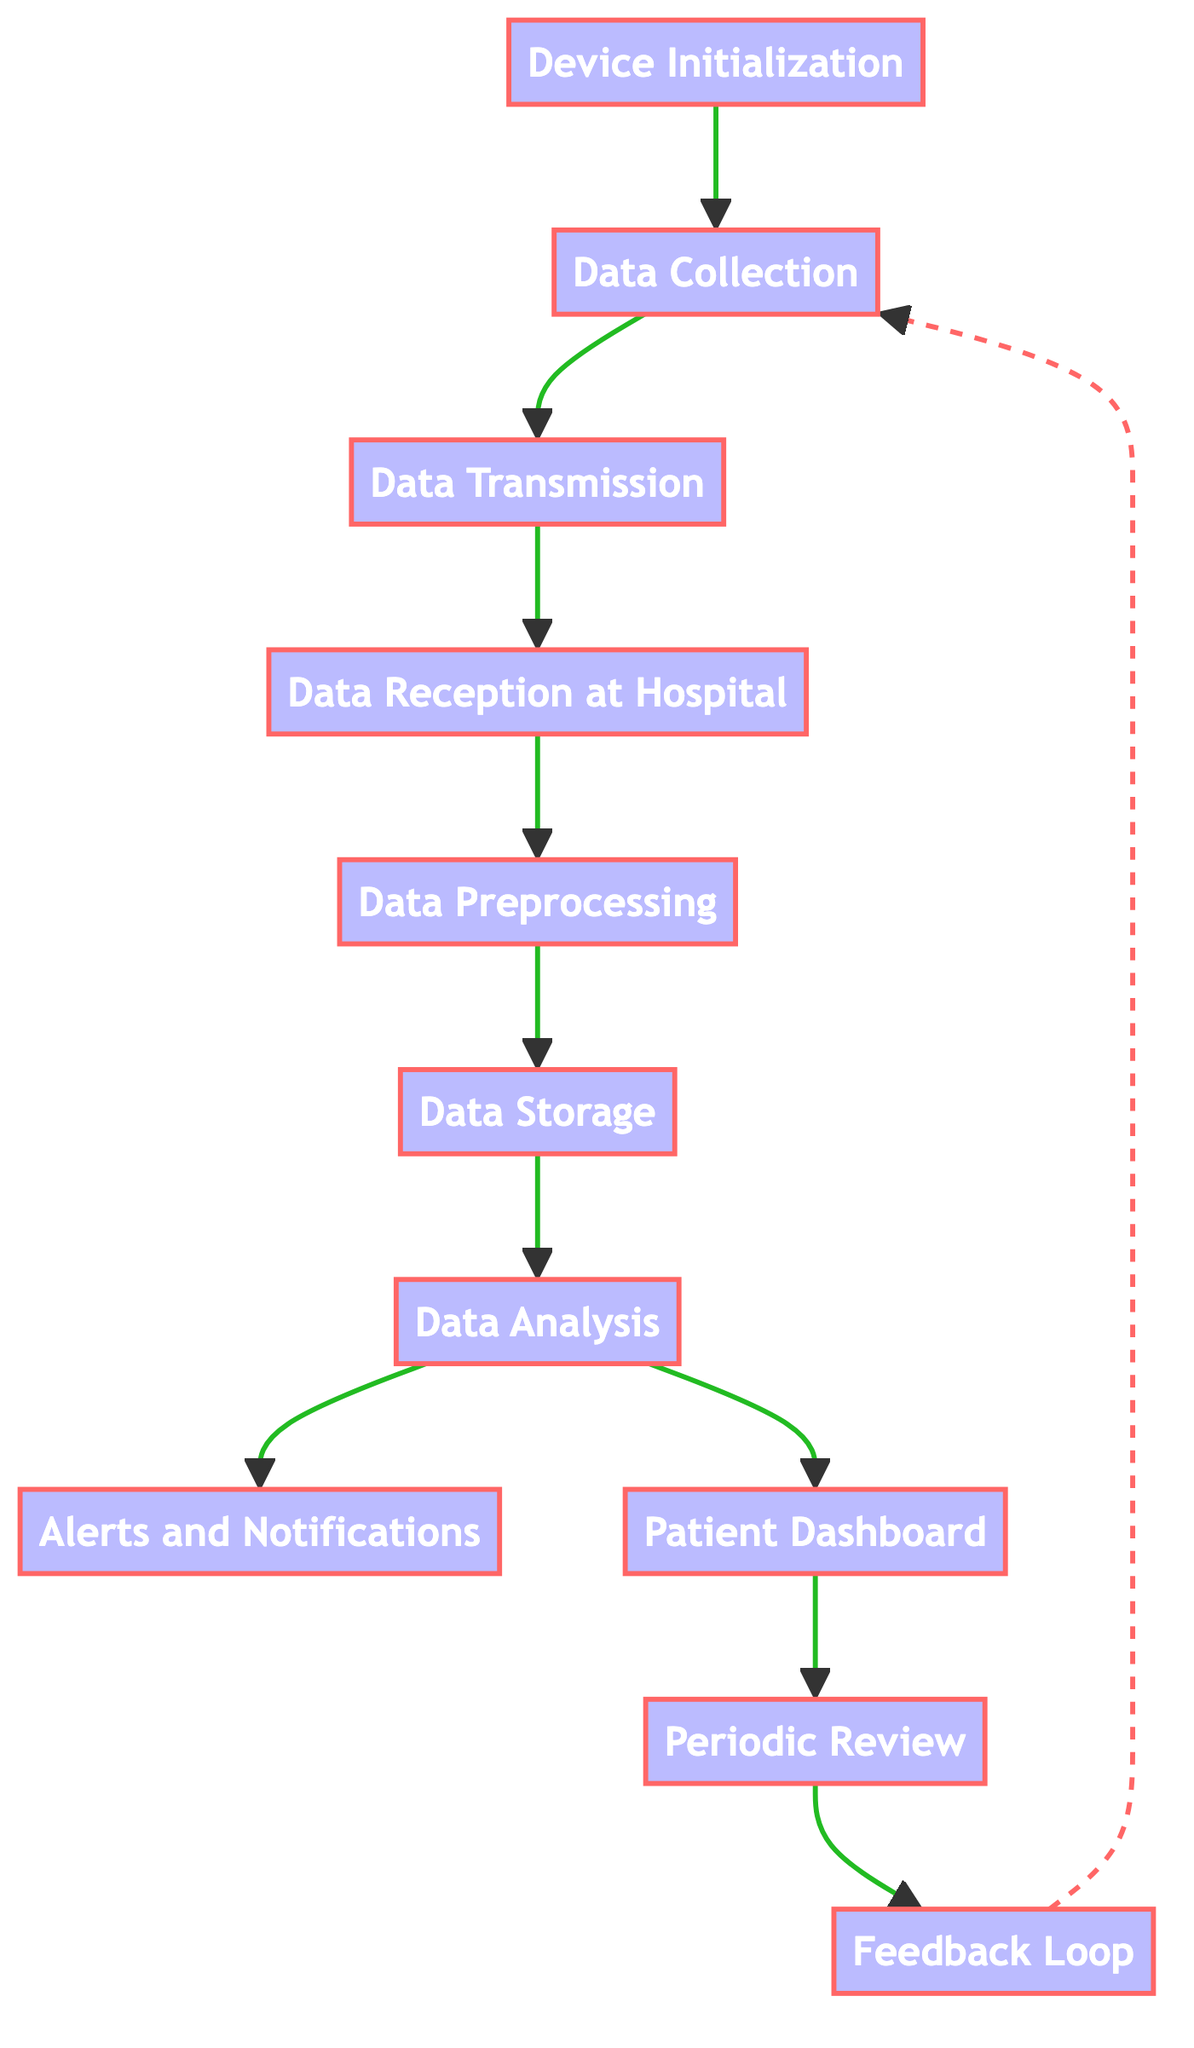What is the first step in the integration process? The diagram shows that the first step is "Device Initialization," which involves setting up the wearable health device and onboarding the user.
Answer: Device Initialization How many steps are involved in the integration process? By counting the nodes in the diagram, there are a total of 10 steps in the process.
Answer: 10 What follows after "Data Collection"? The diagram indicates that "Data Transmission" follows after "Data Collection," as depicted by the arrow connecting these two nodes.
Answer: Data Transmission What is generated after data analysis? The flow chart shows that "Alerts and Notifications" and "Patient Dashboard" are generated as outputs after "Data Analysis."
Answer: Alerts and Notifications, Patient Dashboard What is the purpose of the Feedback Loop? The "Feedback Loop" allows patients to receive feedback and recommendations from healthcare providers through linked mobile applications, which is a part of the continuous care process.
Answer: Patient feedback and recommendations How does data flow from the Patient Dashboard? The diagram states that the "Patient Dashboard" feeds into the "Periodic Review," indicating that the reviewed data is based on the insights visualized in this dashboard.
Answer: Periodic Review Which step ensures compliance with regulations? "Data Storage" is the step that ensures secure storage of preprocessed data while complying with HIPAA and local regulations.
Answer: Data Storage What connections are derived from "Data Analysis"? The diagram shows two connections from "Data Analysis": one leading to "Alerts and Notifications" and the other leading to "Patient Dashboard," indicating these are simultaneous processes following data analysis.
Answer: Alerts and Notifications, Patient Dashboard What type of data transmission is described? The transmission described is "secure transmission" of health data using wireless technologies like Bluetooth or Wi-Fi, focusing on maintaining data security.
Answer: Secure transmission 